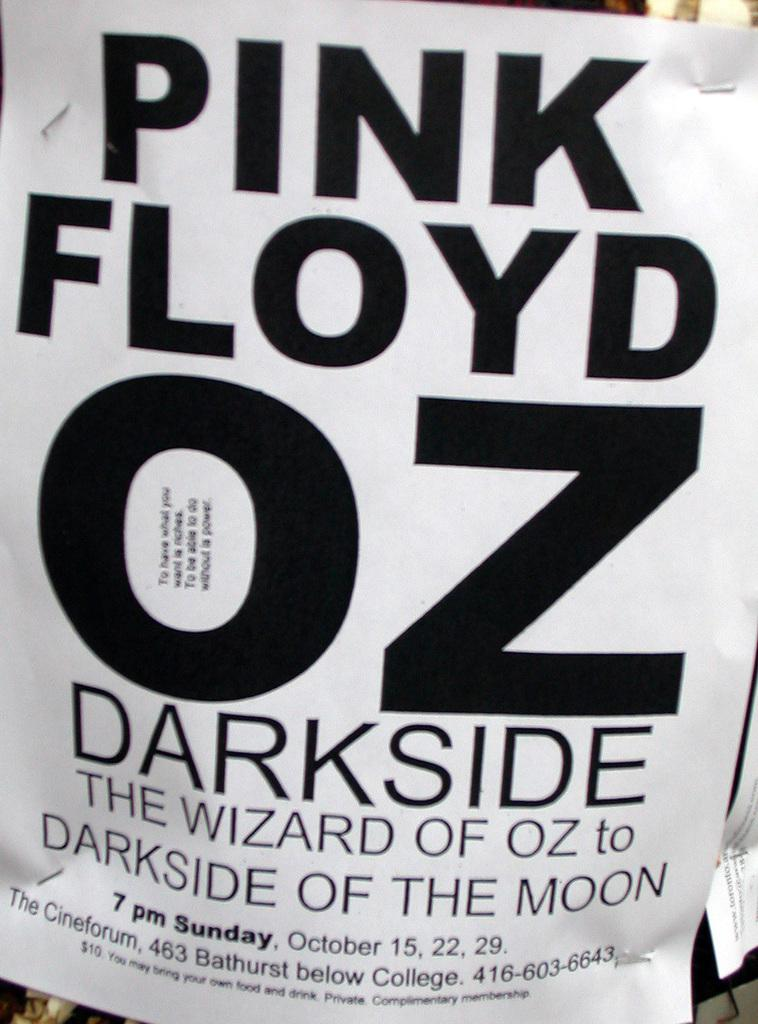What is the main subject in the middle of the image? There is a poster in the middle of the image. What types of elements are present on the poster? The poster contains alphabets and numbers. Can you see a snail crawling on the poster in the image? No, there is no snail present on the poster or in the image. 